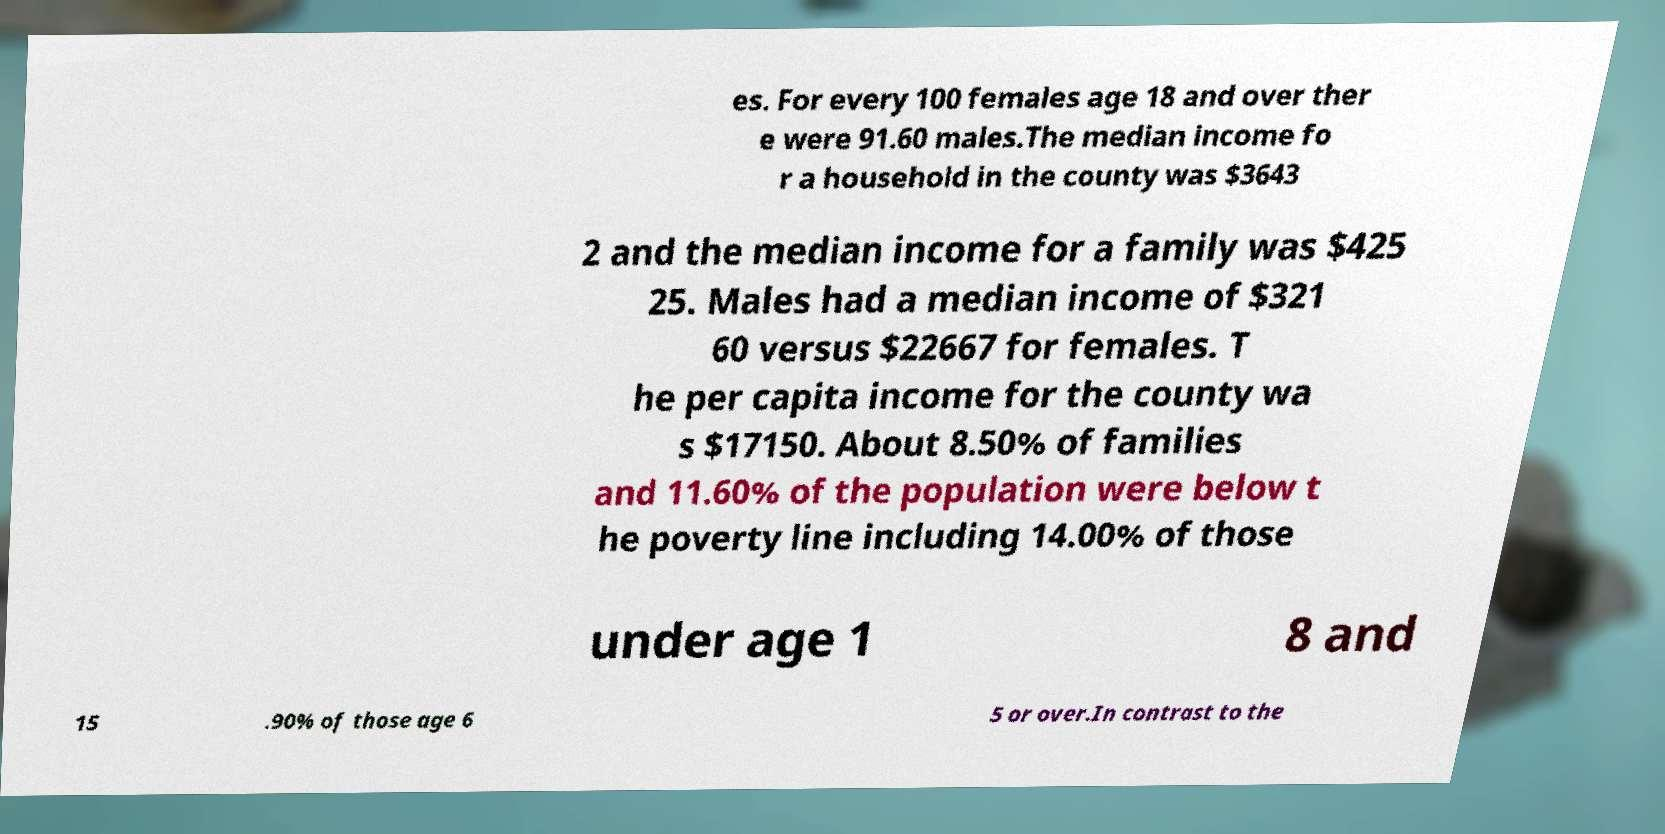Can you accurately transcribe the text from the provided image for me? es. For every 100 females age 18 and over ther e were 91.60 males.The median income fo r a household in the county was $3643 2 and the median income for a family was $425 25. Males had a median income of $321 60 versus $22667 for females. T he per capita income for the county wa s $17150. About 8.50% of families and 11.60% of the population were below t he poverty line including 14.00% of those under age 1 8 and 15 .90% of those age 6 5 or over.In contrast to the 